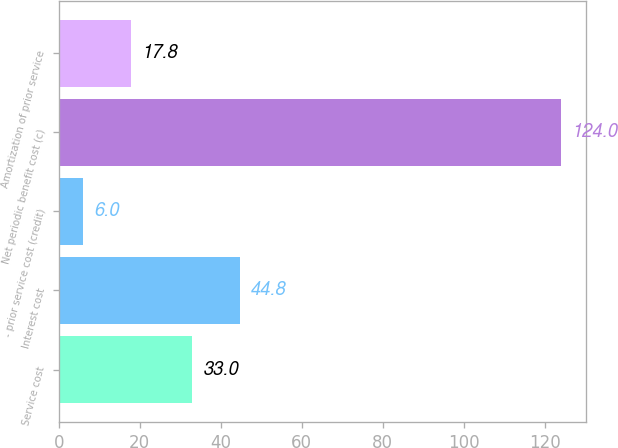Convert chart to OTSL. <chart><loc_0><loc_0><loc_500><loc_500><bar_chart><fcel>Service cost<fcel>Interest cost<fcel>- prior service cost (credit)<fcel>Net periodic benefit cost (c)<fcel>Amortization of prior service<nl><fcel>33<fcel>44.8<fcel>6<fcel>124<fcel>17.8<nl></chart> 